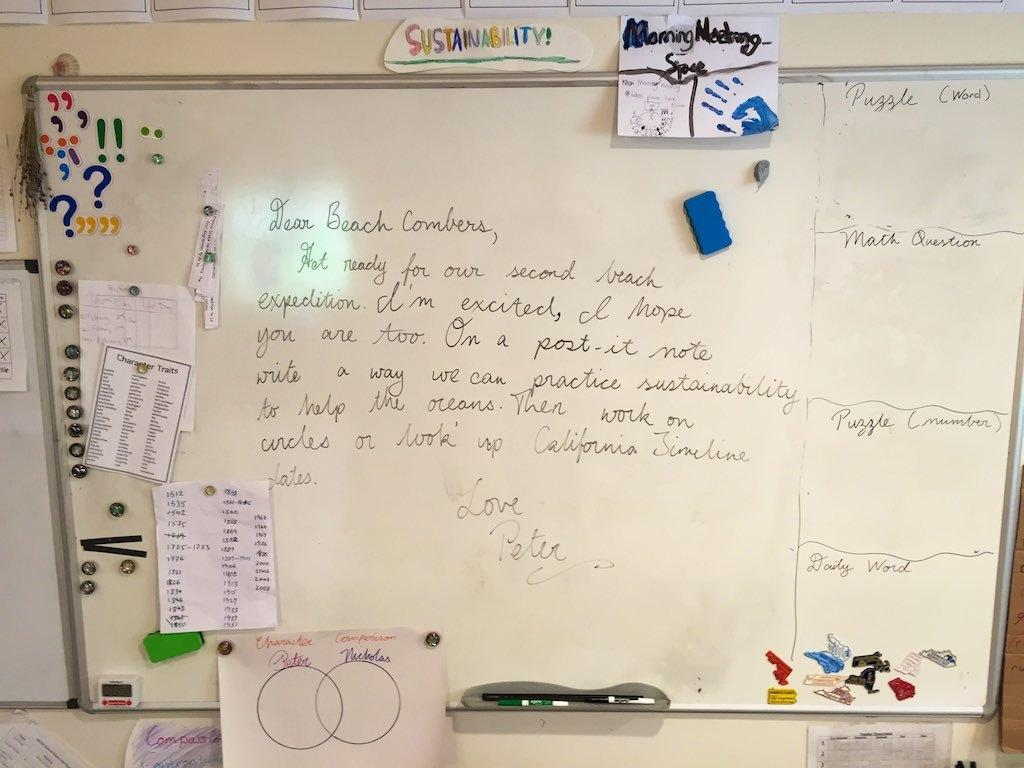<image>
Describe the image concisely. the words dear beach that are on a white board 